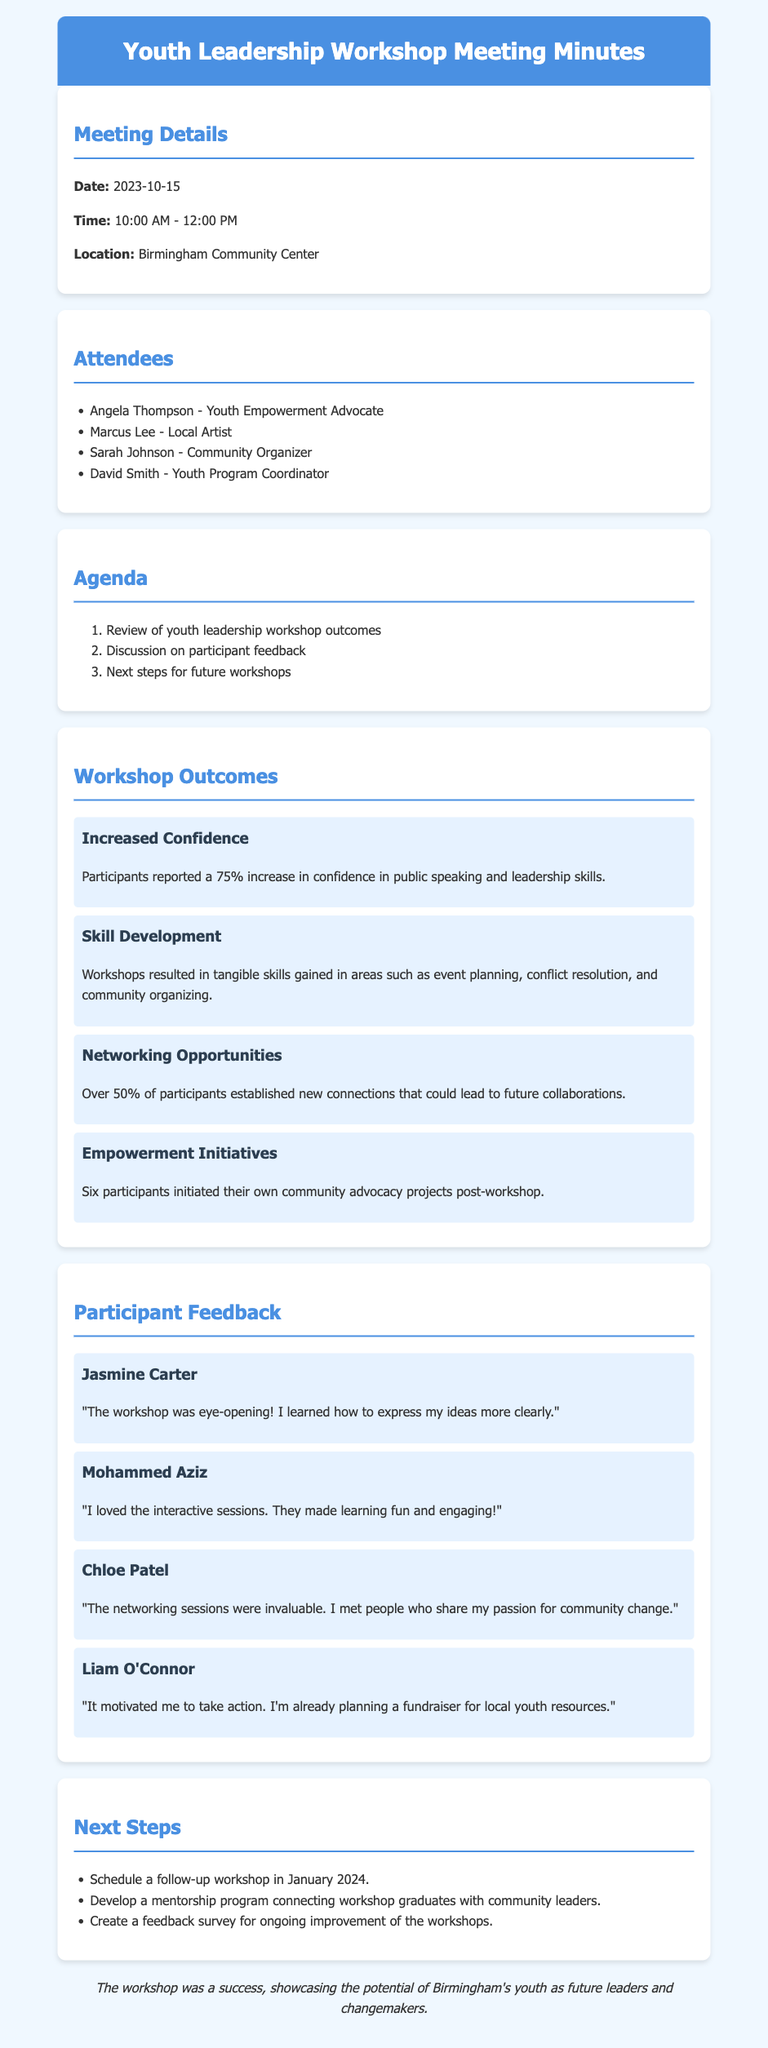what was the date of the workshop? The date mentioned in the document is the date when the workshop took place.
Answer: 2023-10-15 how many attendees were listed? The document provides a list of individuals who attended the workshop, indicating the total number of attendees.
Answer: 4 what percentage of participants reported increased confidence? The document specifies the percentage of participants who felt an increase in their confidence levels.
Answer: 75% which participant initiated a fundraiser for local youth resources? The document contains feedback from various participants, including one who mentioned their plans for fundraising.
Answer: Liam O'Connor how many new connections were established by participants? The document states the percentage of participants who established new networking connections during the workshop.
Answer: 50% what is the goal of the proposed mentorship program? The document outlines next steps and mentions the aim of developing a mentorship program.
Answer: Connecting workshop graduates with community leaders who expressed that the interactive sessions made learning fun? The feedback section includes specific comments from participants, including one who appreciated the interactive aspect.
Answer: Mohammed Aziz how many empowerment initiatives were reported after the workshop? The outcomes section notes the number of participants who initiated projects post-workshop.
Answer: 6 when is the follow-up workshop scheduled? The next steps in the document indicate the planned timing for the follow-up workshop.
Answer: January 2024 